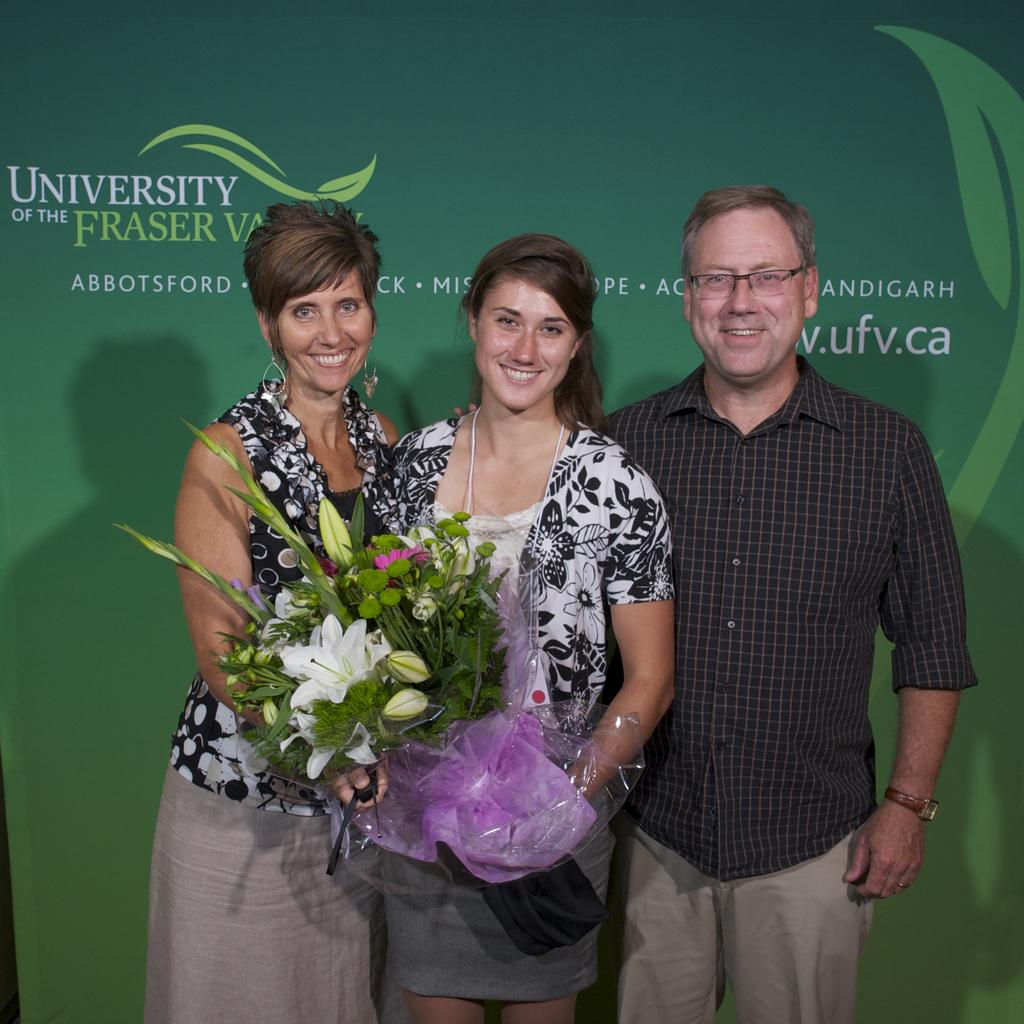How many people are present in the image? There are three people standing in the image. What is the facial expression of the people in the image? The people are smiling. What are two of the people holding in the image? Two women are holding a flower bouquet. What can be seen in the background of the image? There is a banner visible in the background of the image. What type of pizzas are being served at the event in the image? There is no mention of pizzas or an event in the image; it simply shows three people smiling and holding a flower bouquet. Can you hear the thunder in the image? There is no sound or indication of thunder in the image; it is a still photograph. 